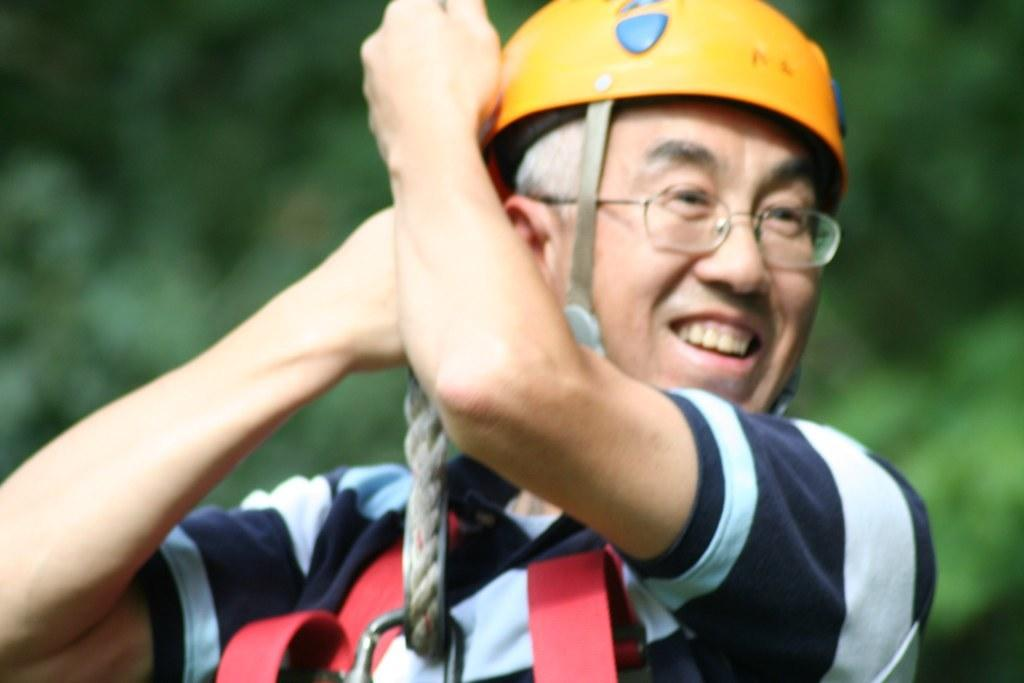Where was the image taken? The image was taken outdoors. What can be seen in the background of the image? There are trees in the background of the image. Who is the main subject in the image? There is a man in the middle of the image. What is the man's facial expression? The man has a smiling face. What is the man holding in the image? The man is holding a rope with his hands. What type of nail is the man hammering into the tree in the image? There is no nail or tree present in the image; the man is holding a rope. What joke is the man telling in the image? There is no indication of a joke being told in the image; the man has a smiling face, but no conversation or context is provided. 